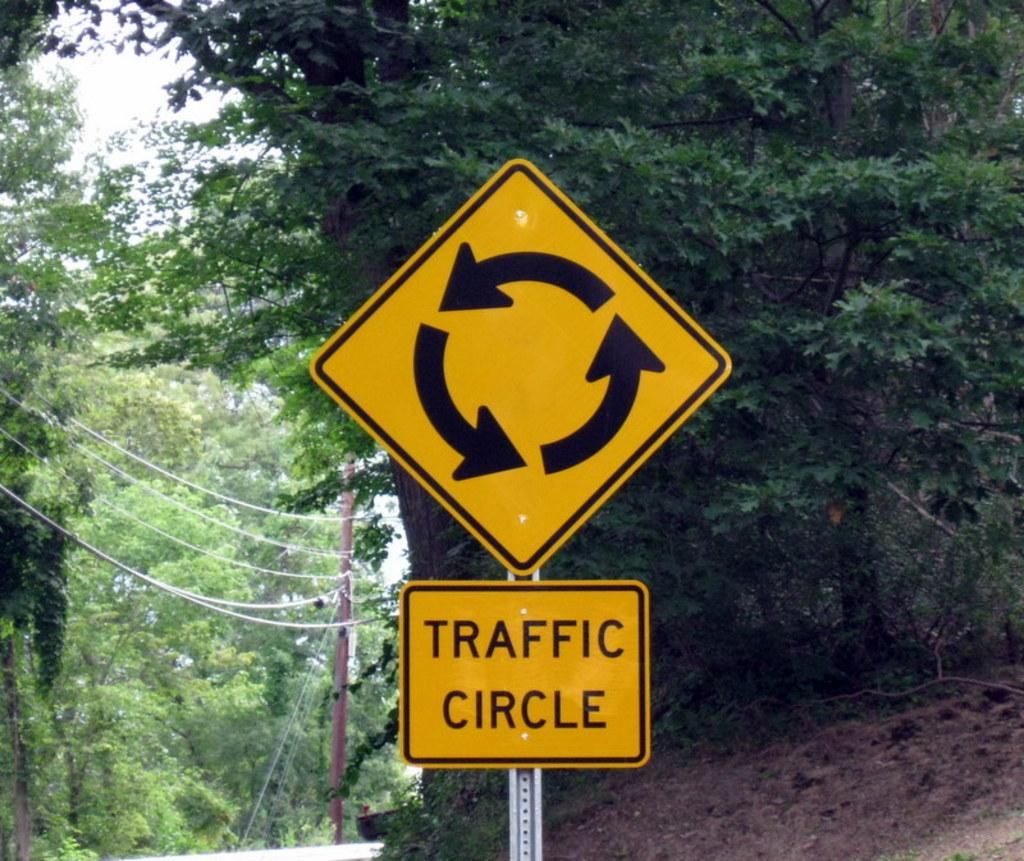<image>
Offer a succinct explanation of the picture presented. A yellow sign warning motorists that a traffic Circle is upcoming. 